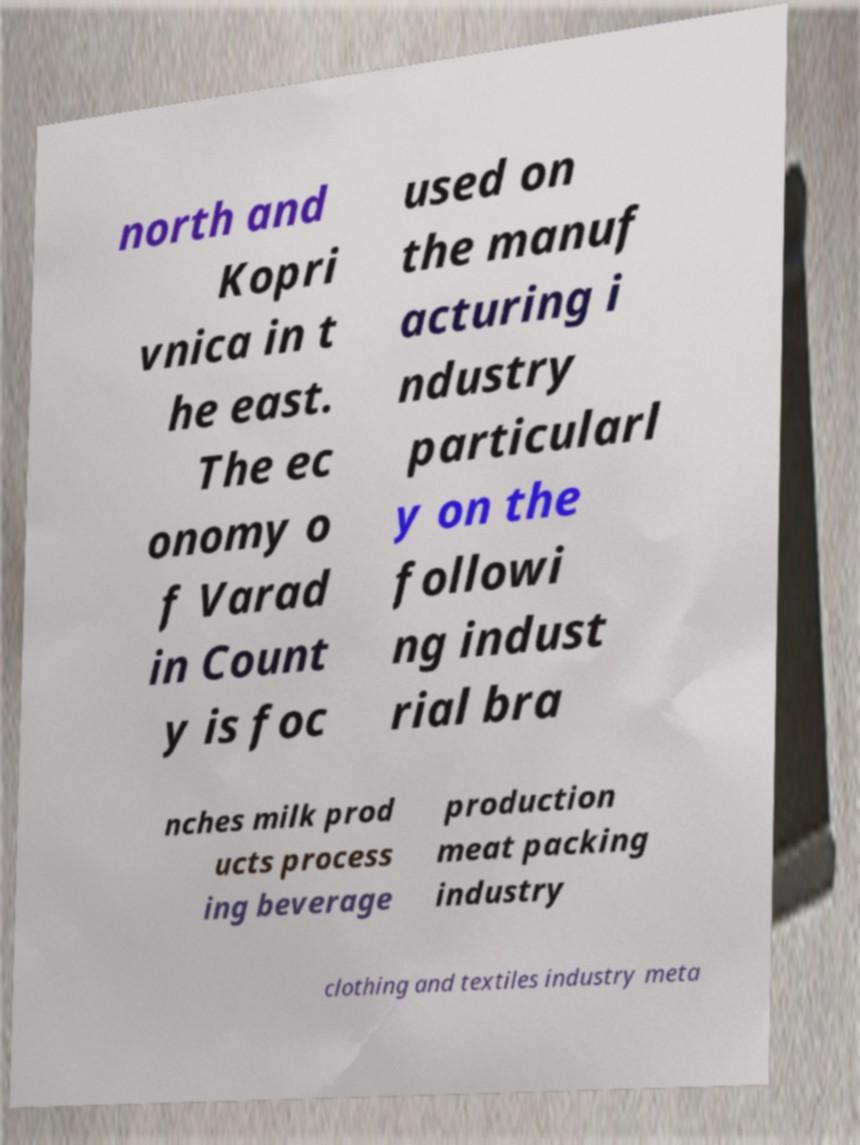Please identify and transcribe the text found in this image. north and Kopri vnica in t he east. The ec onomy o f Varad in Count y is foc used on the manuf acturing i ndustry particularl y on the followi ng indust rial bra nches milk prod ucts process ing beverage production meat packing industry clothing and textiles industry meta 